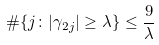Convert formula to latex. <formula><loc_0><loc_0><loc_500><loc_500>\# \{ j \colon | \gamma _ { 2 j } | \geq \lambda \} \leq \frac { 9 } { \lambda }</formula> 